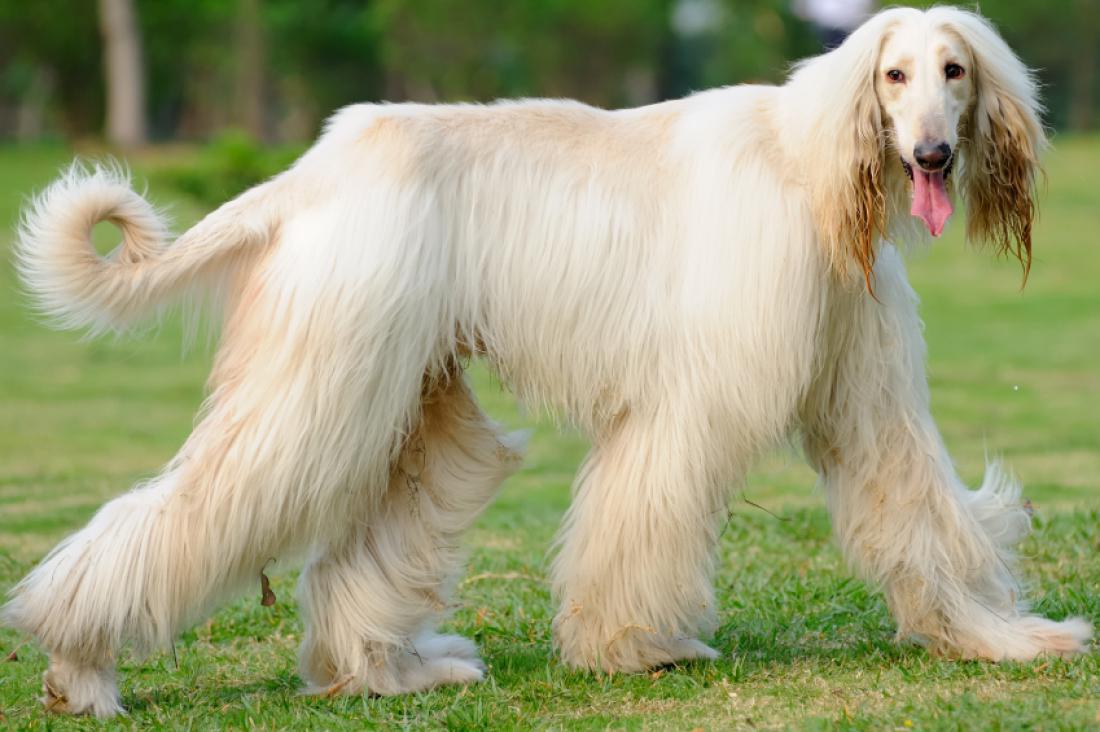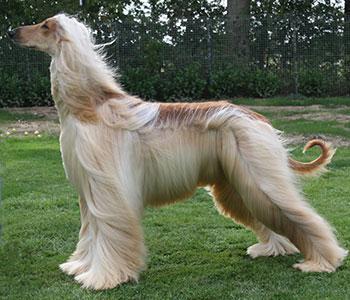The first image is the image on the left, the second image is the image on the right. Examine the images to the left and right. Is the description "In at least one image, there is a single dog with brown tipped ears and small curled tail, facing left with its feet on grass." accurate? Answer yes or no. Yes. The first image is the image on the left, the second image is the image on the right. For the images shown, is this caption "At least one of the dogs is standing, and you can see a full body shot of the standing dog." true? Answer yes or no. Yes. 